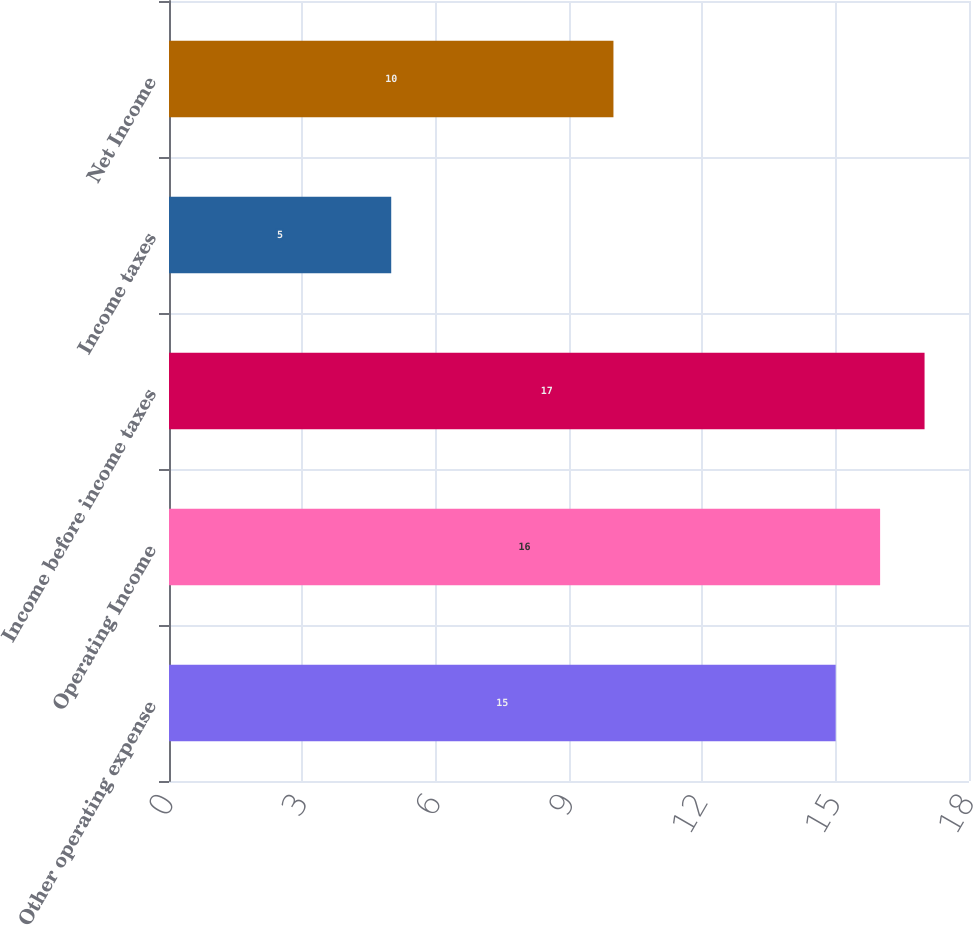Convert chart. <chart><loc_0><loc_0><loc_500><loc_500><bar_chart><fcel>Other operating expense<fcel>Operating Income<fcel>Income before income taxes<fcel>Income taxes<fcel>Net Income<nl><fcel>15<fcel>16<fcel>17<fcel>5<fcel>10<nl></chart> 